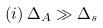Convert formula to latex. <formula><loc_0><loc_0><loc_500><loc_500>( i ) \, \Delta _ { A } \gg \Delta _ { s }</formula> 